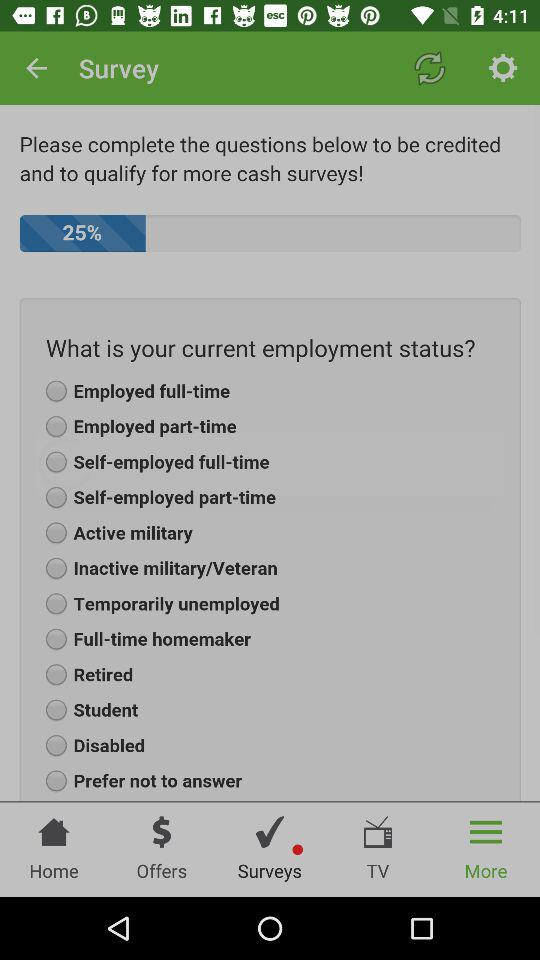How many brands are mentioned?
Answer the question using a single word or phrase. 3 